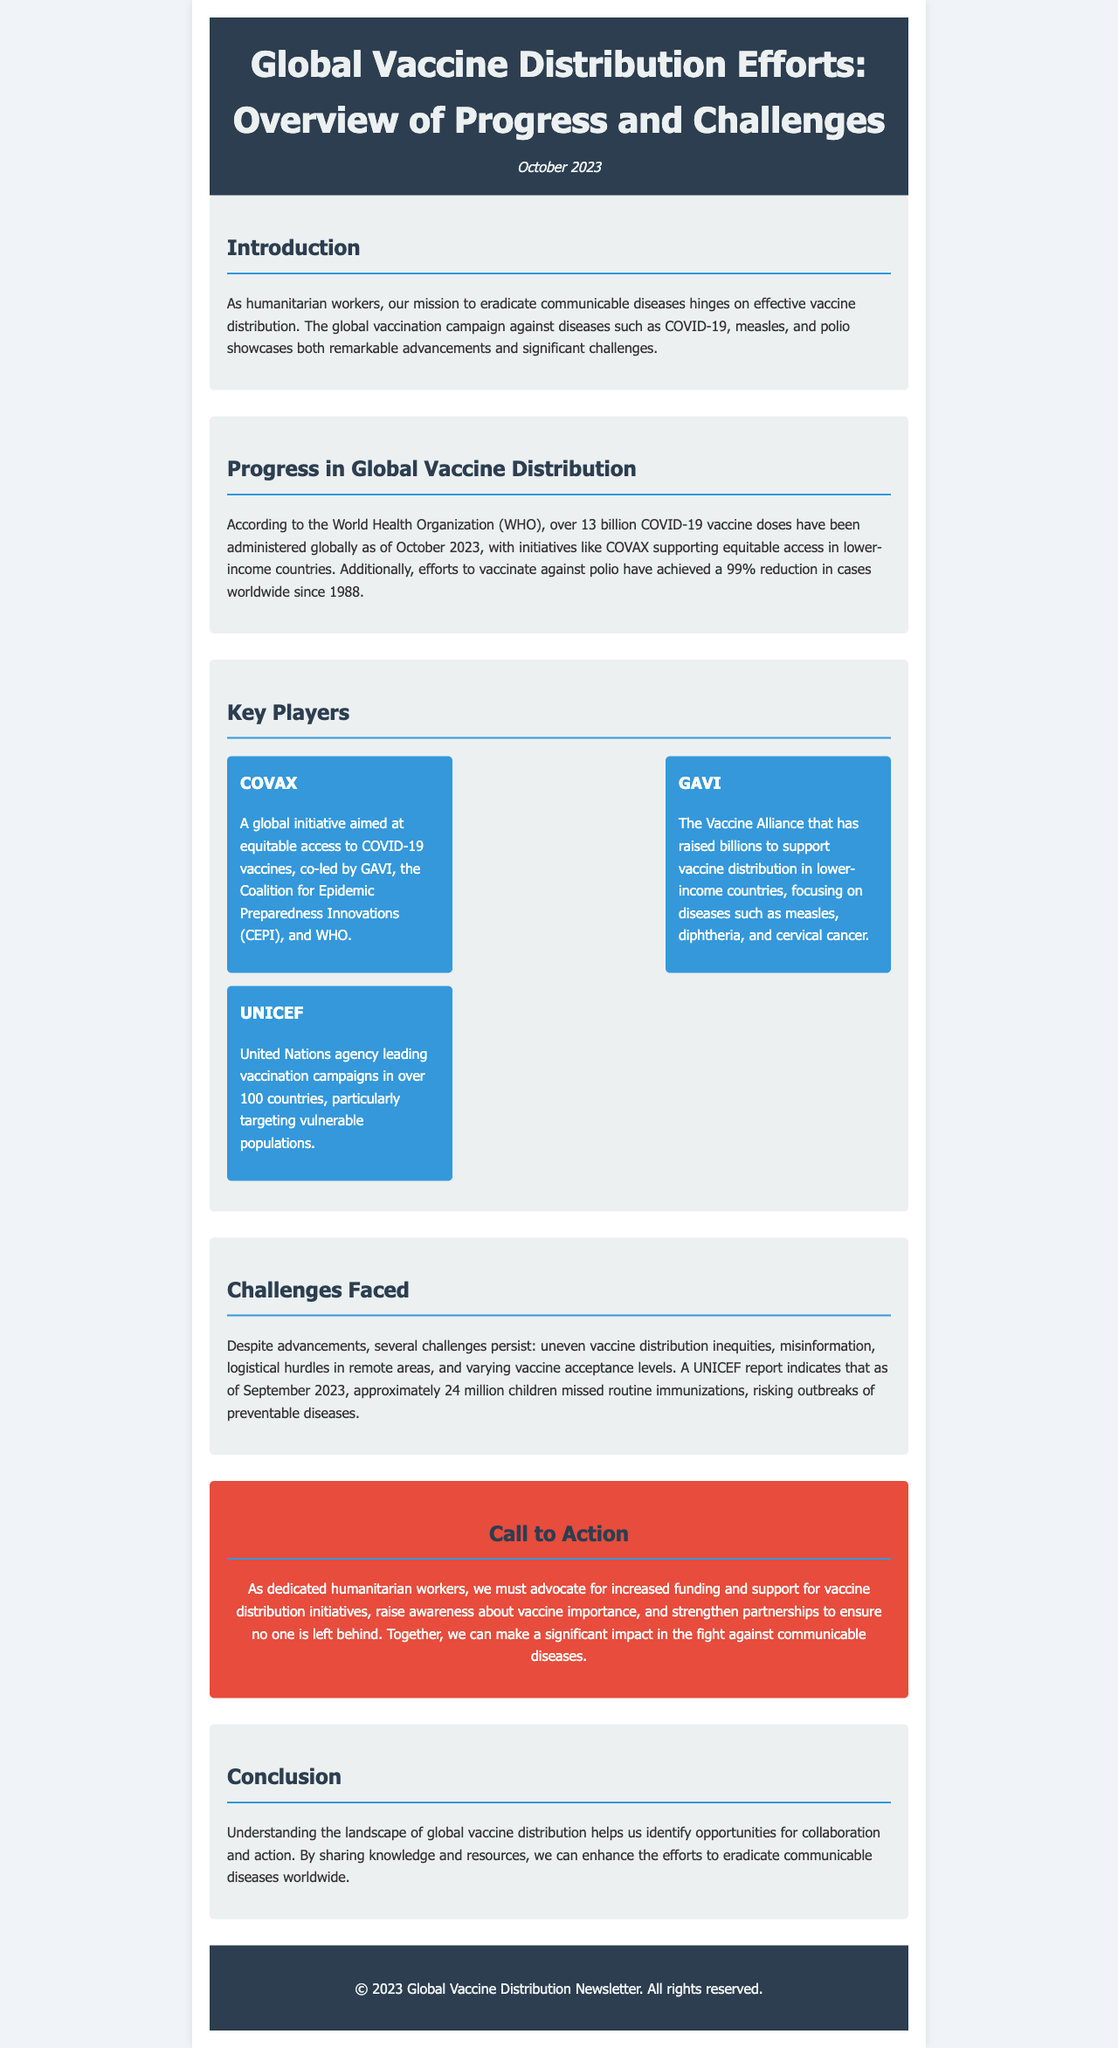What is the title of the newsletter? The title of the newsletter is stated prominently at the top of the document.
Answer: Global Vaccine Distribution Efforts: Overview of Progress and Challenges How many COVID-19 vaccine doses have been administered globally? The document mentions a specific number of COVID-19 vaccine doses administered as of October 2023.
Answer: Over 13 billion What percentage reduction in polio cases has been achieved since 1988? The newsletter provides a specific statistic regarding the reduction of polio cases globally.
Answer: 99% Which organization co-leads COVAX? The document lists key organizations involved in the COVAX initiative.
Answer: WHO What significant challenge is mentioned regarding vaccine distribution? The document highlights a specific challenge related to vaccine distribution that impacts effectiveness.
Answer: Uneven vaccine distribution inequities What role does UNICEF play in vaccine distribution? The newsletter describes the specific function of UNICEF in the vaccine distribution process.
Answer: Leading vaccination campaigns What is the primary call to action for humanitarian workers? The document summarizes the main call to action for its readers regarding vaccine distribution initiatives.
Answer: Advocate for increased funding What is one reason children missed routine immunizations? The newsletter states a specific statistic about children missing vaccinations and implies reasons behind it.
Answer: Misinformation 